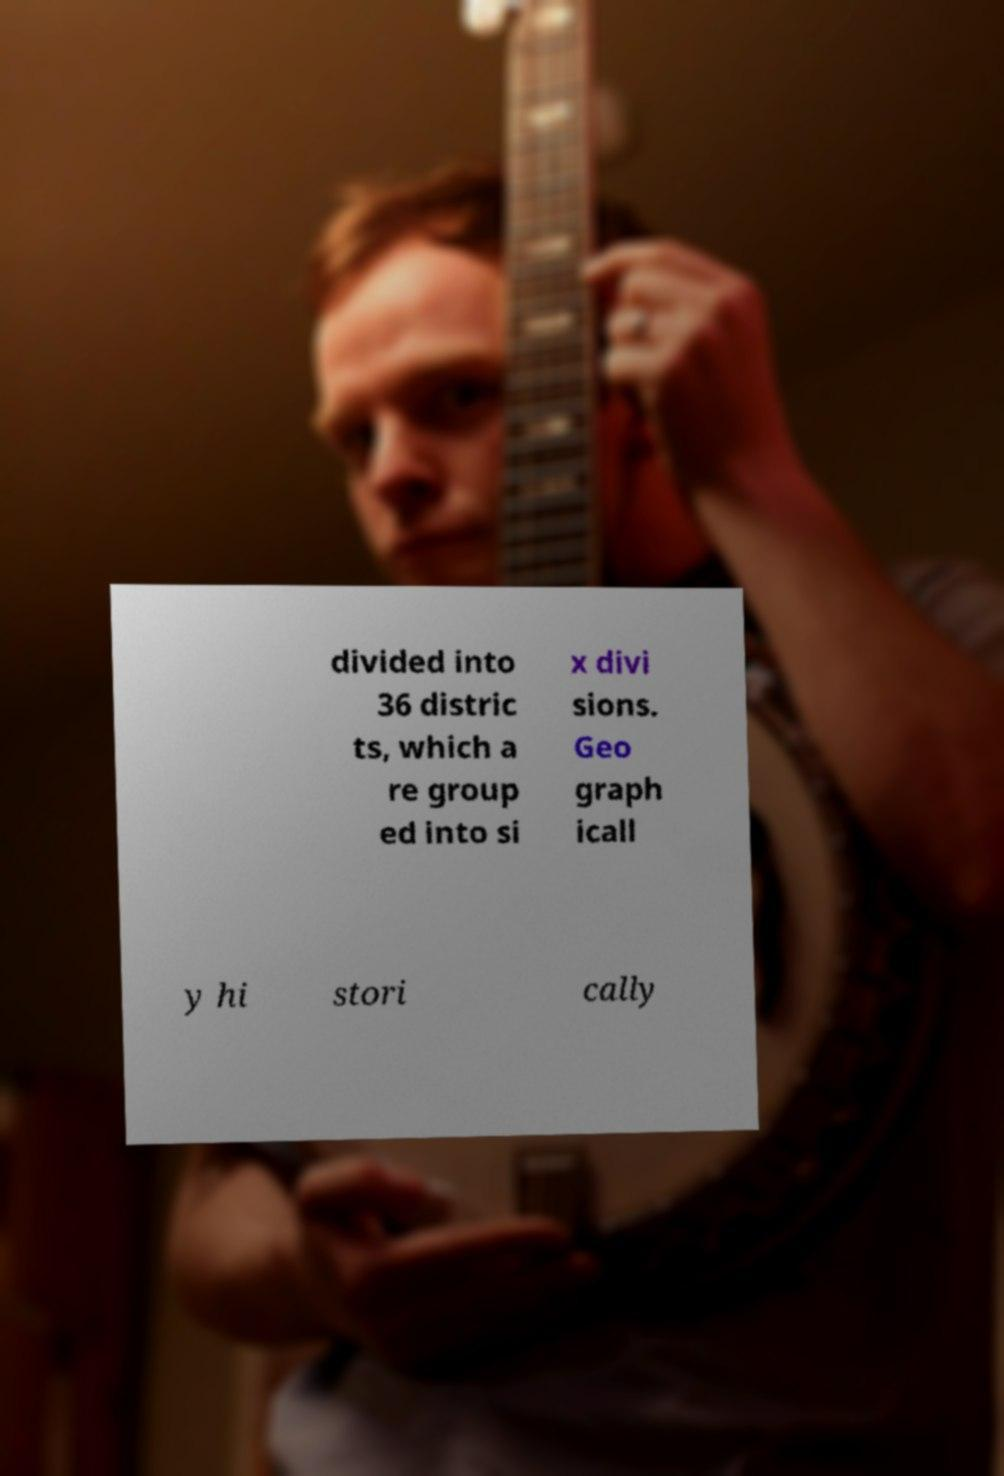Please identify and transcribe the text found in this image. divided into 36 distric ts, which a re group ed into si x divi sions. Geo graph icall y hi stori cally 